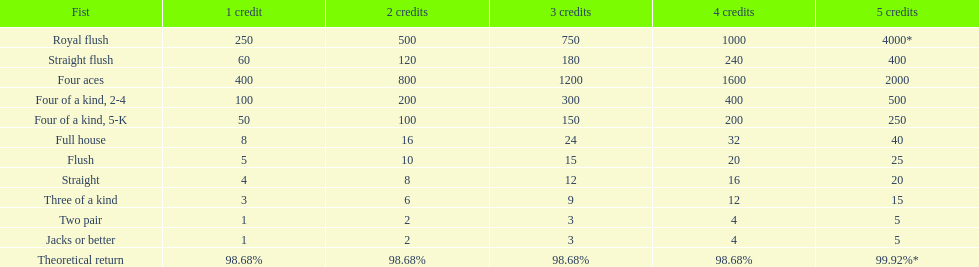Parse the full table. {'header': ['Fist', '1 credit', '2 credits', '3 credits', '4 credits', '5 credits'], 'rows': [['Royal flush', '250', '500', '750', '1000', '4000*'], ['Straight flush', '60', '120', '180', '240', '400'], ['Four aces', '400', '800', '1200', '1600', '2000'], ['Four of a kind, 2-4', '100', '200', '300', '400', '500'], ['Four of a kind, 5-K', '50', '100', '150', '200', '250'], ['Full house', '8', '16', '24', '32', '40'], ['Flush', '5', '10', '15', '20', '25'], ['Straight', '4', '8', '12', '16', '20'], ['Three of a kind', '3', '6', '9', '12', '15'], ['Two pair', '1', '2', '3', '4', '5'], ['Jacks or better', '1', '2', '3', '4', '5'], ['Theoretical return', '98.68%', '98.68%', '98.68%', '98.68%', '99.92%*']]} Is a 2 credit full house the same as a 5 credit three of a kind? No. 